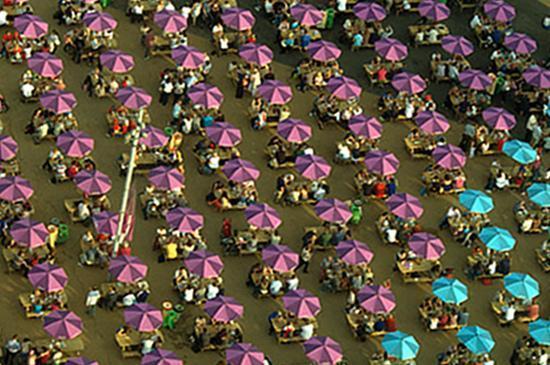How many elephants are there?
Give a very brief answer. 0. 